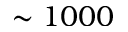<formula> <loc_0><loc_0><loc_500><loc_500>\sim 1 0 0 0</formula> 